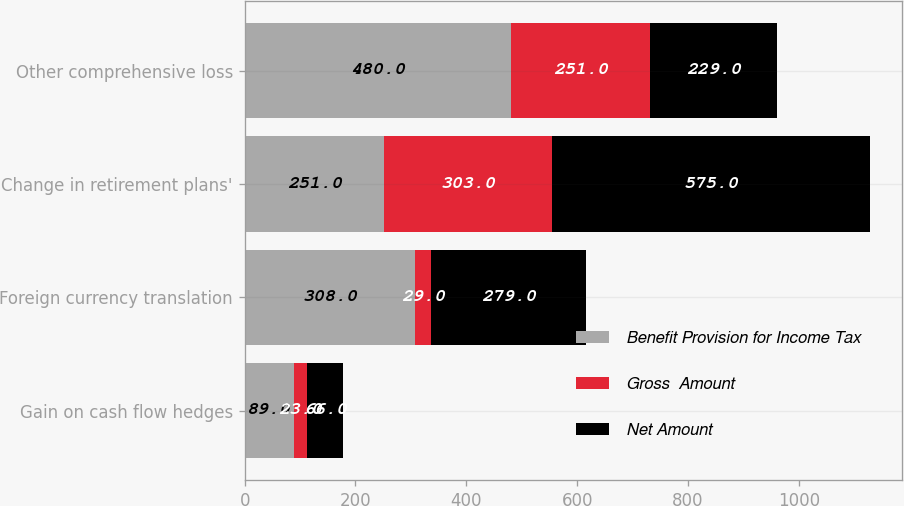Convert chart. <chart><loc_0><loc_0><loc_500><loc_500><stacked_bar_chart><ecel><fcel>Gain on cash flow hedges<fcel>Foreign currency translation<fcel>Change in retirement plans'<fcel>Other comprehensive loss<nl><fcel>Benefit Provision for Income Tax<fcel>89<fcel>308<fcel>251<fcel>480<nl><fcel>Gross  Amount<fcel>23<fcel>29<fcel>303<fcel>251<nl><fcel>Net Amount<fcel>66<fcel>279<fcel>575<fcel>229<nl></chart> 